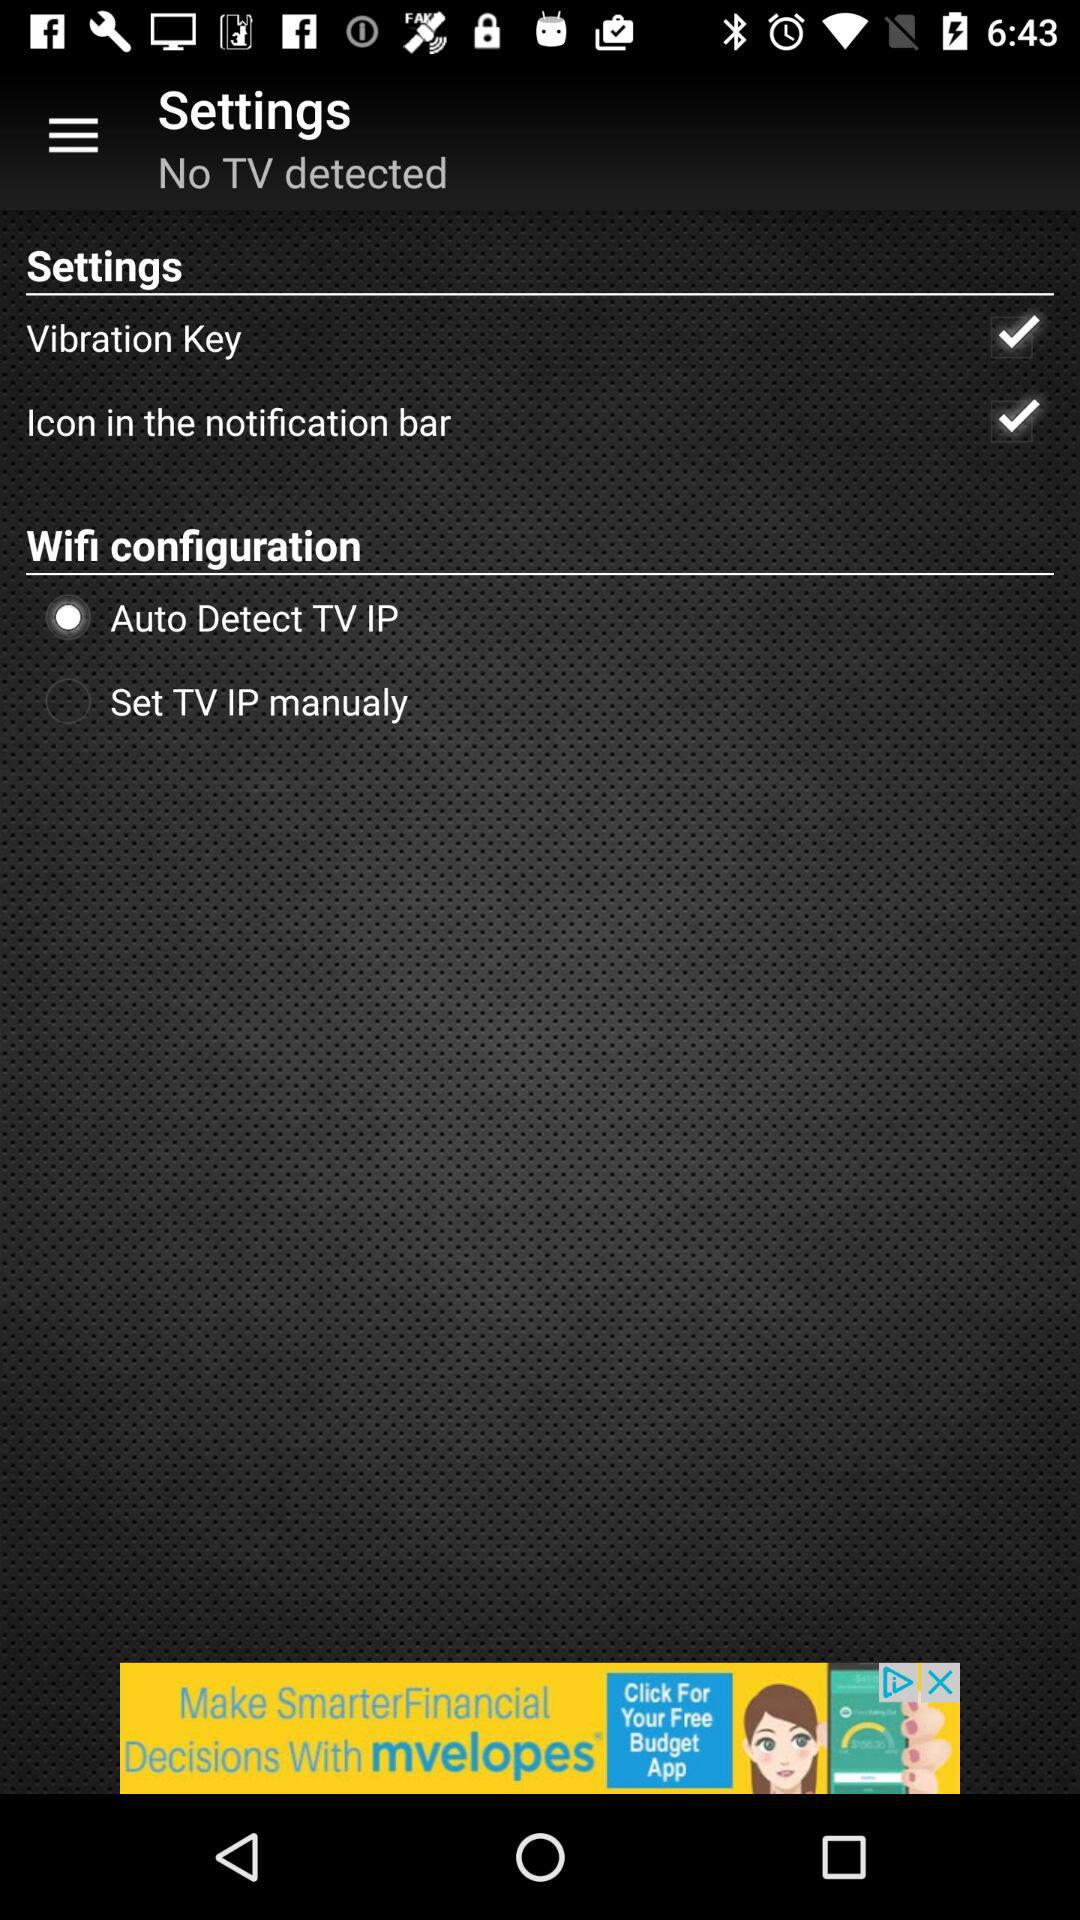What is the status of the "Icon in the notification bar"? The status of the "Icon in the notification bar" is "on". 